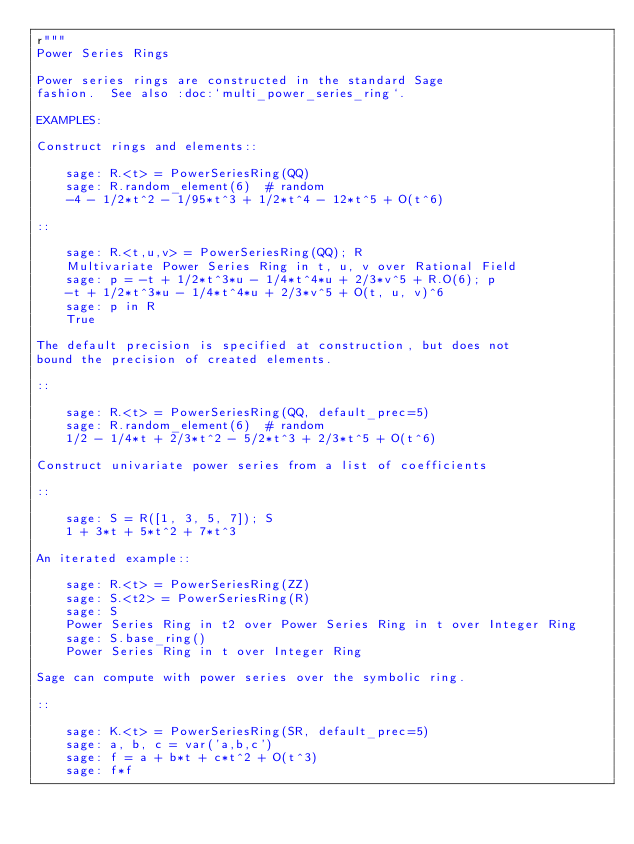Convert code to text. <code><loc_0><loc_0><loc_500><loc_500><_Python_>r"""
Power Series Rings

Power series rings are constructed in the standard Sage
fashion.  See also :doc:`multi_power_series_ring`.

EXAMPLES:

Construct rings and elements::

    sage: R.<t> = PowerSeriesRing(QQ)
    sage: R.random_element(6)  # random
    -4 - 1/2*t^2 - 1/95*t^3 + 1/2*t^4 - 12*t^5 + O(t^6)

::

    sage: R.<t,u,v> = PowerSeriesRing(QQ); R
    Multivariate Power Series Ring in t, u, v over Rational Field
    sage: p = -t + 1/2*t^3*u - 1/4*t^4*u + 2/3*v^5 + R.O(6); p
    -t + 1/2*t^3*u - 1/4*t^4*u + 2/3*v^5 + O(t, u, v)^6
    sage: p in R
    True

The default precision is specified at construction, but does not
bound the precision of created elements.

::

    sage: R.<t> = PowerSeriesRing(QQ, default_prec=5)
    sage: R.random_element(6)  # random
    1/2 - 1/4*t + 2/3*t^2 - 5/2*t^3 + 2/3*t^5 + O(t^6)

Construct univariate power series from a list of coefficients

::

    sage: S = R([1, 3, 5, 7]); S
    1 + 3*t + 5*t^2 + 7*t^3

An iterated example::

    sage: R.<t> = PowerSeriesRing(ZZ)
    sage: S.<t2> = PowerSeriesRing(R)
    sage: S
    Power Series Ring in t2 over Power Series Ring in t over Integer Ring
    sage: S.base_ring()
    Power Series Ring in t over Integer Ring

Sage can compute with power series over the symbolic ring.

::

    sage: K.<t> = PowerSeriesRing(SR, default_prec=5)
    sage: a, b, c = var('a,b,c')
    sage: f = a + b*t + c*t^2 + O(t^3)
    sage: f*f</code> 